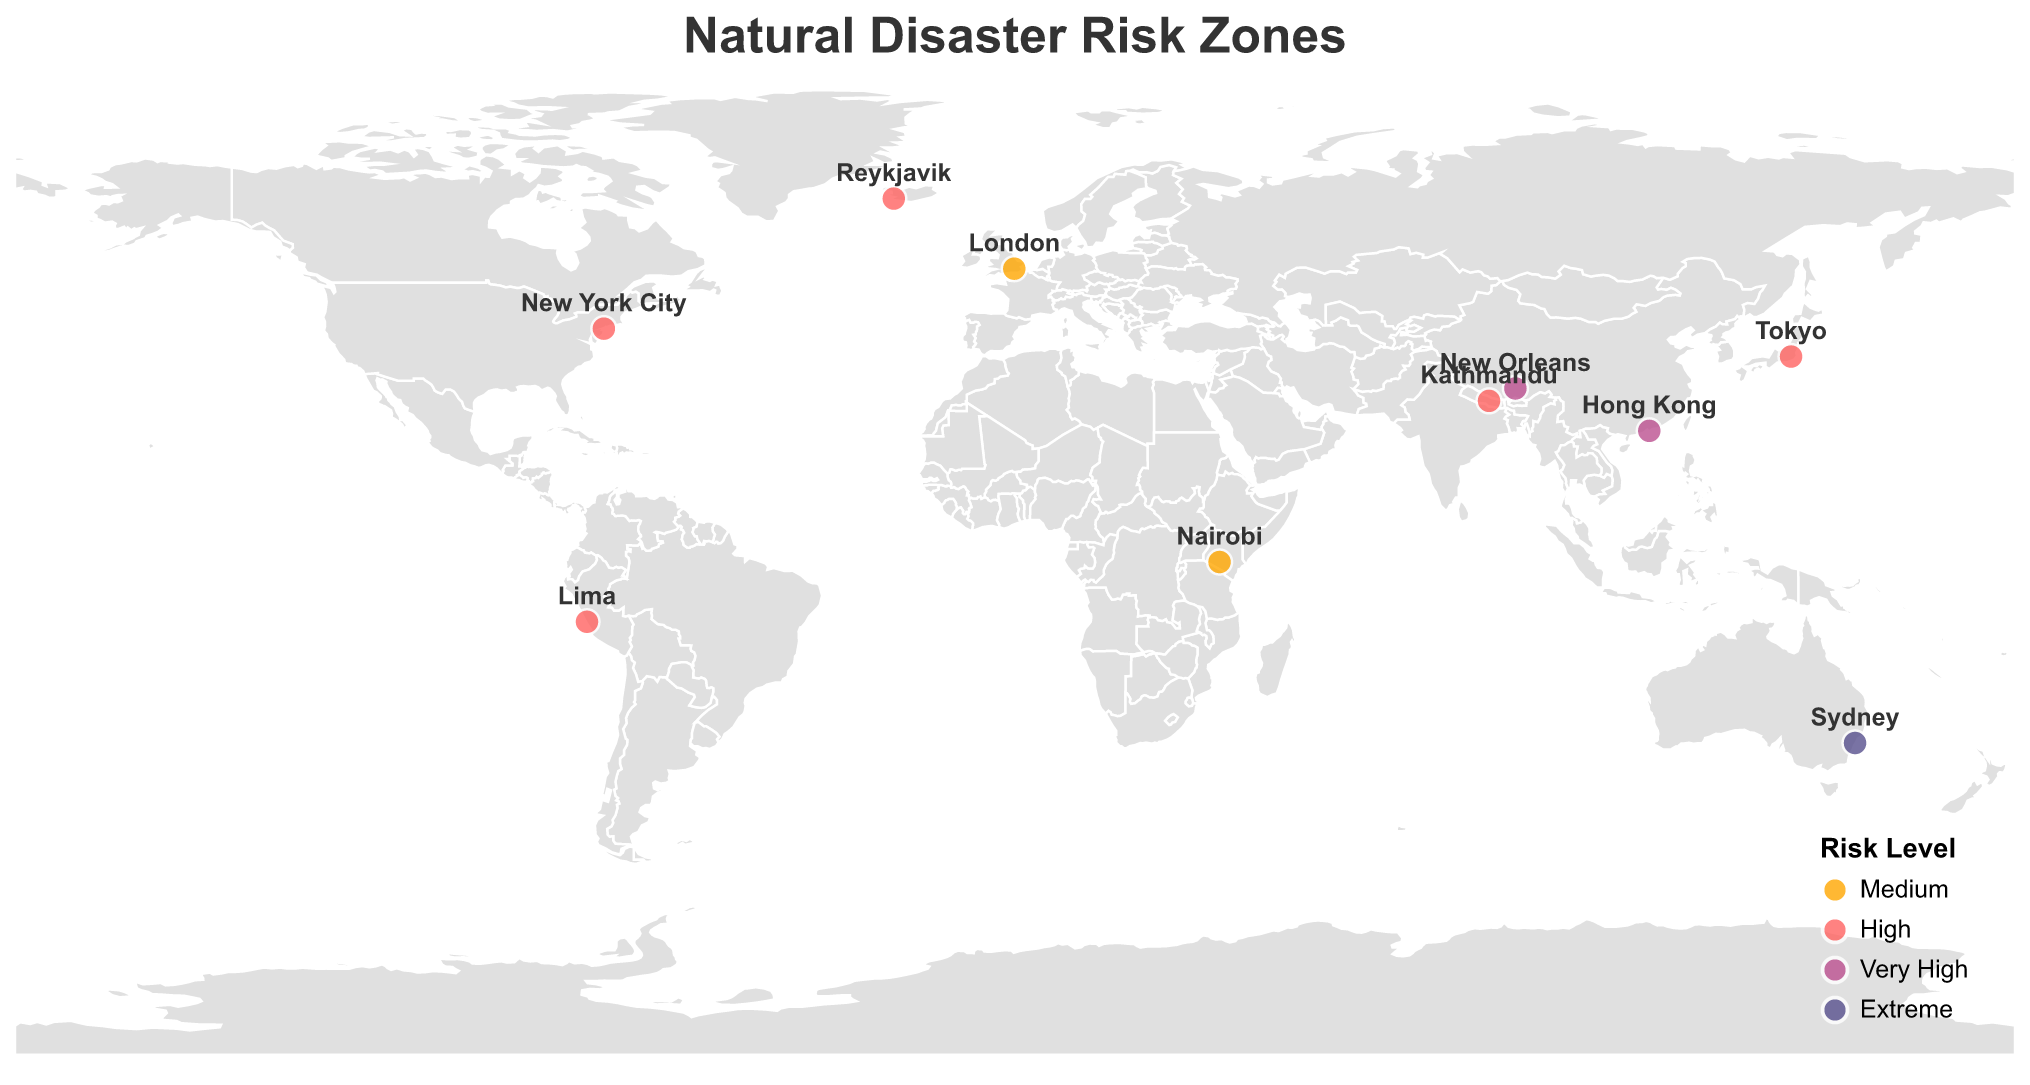How many different disaster types are represented in the figure? The tooltip and data points indicate each disaster type: Earthquake, Bushfire, Hurricane, Landslide, Flash Flood, Volcanic Eruption, Typhoon, Tsunami, Heatwave, and Blizzard. Count each unique disaster.
Answer: 10 What location has the highest risk level, and what is the disaster associated with it? According to the color coding and legend in the figure, Sydney has the Extreme risk level. The tooltip tells us the disaster is Bushfire.
Answer: Sydney, Bushfire Which two locations have the same risk level and are closest to each other geographically? By checking the map and risk level colors, London and Nairobi both have a Medium risk level. Geographically, they appear closest on the map.
Answer: London and Nairobi What is the risk level and footage potential for New Orleans? Refer to the tooltip for New Orleans, which shows both the risk level and footage potential.
Answer: Very High, Storm surge flooding streets Comparing Tokyo and Kathmandu, which has a higher risk level, and what is the difference in their disaster types? The color coding indicates both have a High risk level. The disaster type for Tokyo is Earthquake, and for Kathmandu, it's Landslide.
Answer: Same, Earthquake vs. Landslide What is the visual cue used to indicate different risk levels on the map? The risk levels are represented by different circle colors according to the legend: Medium (orange), High (red), Very High (purple), and Extreme (dark blue).
Answer: Circle colors Which location offers the highest footage potential based on the description given? The descriptions in Footage Potential highlight dramatic visuals. Sydney's "Firefighters battling flames" during a Bushfire is noted as Extreme risk and seems the most visually compelling.
Answer: Sydney What disaster-related event is illustrated for Reykjavik, and how does its risk level compare to that of Lima? Tooltip information for Reykjavik shows Volcanic Eruption with a High risk level, while Lima also has a High risk level with a Tsunami event.
Answer: Volcanic Eruption, same risk level How does the risk level distribution look across continents? By observing the circle colors across different continents, it appears that risk levels vary, with several high and very high levels spread globally, including North America, Asia, and Australia.
Answer: Varied distribution Which disaster in the figure is associated with disrupting urban infrastructure, and what is its risk level? Observing the tooltip information, New York City (Blizzard) shows stranded vehicles on snow-covered streets, and the risk level is High.
Answer: Blizzard, High 